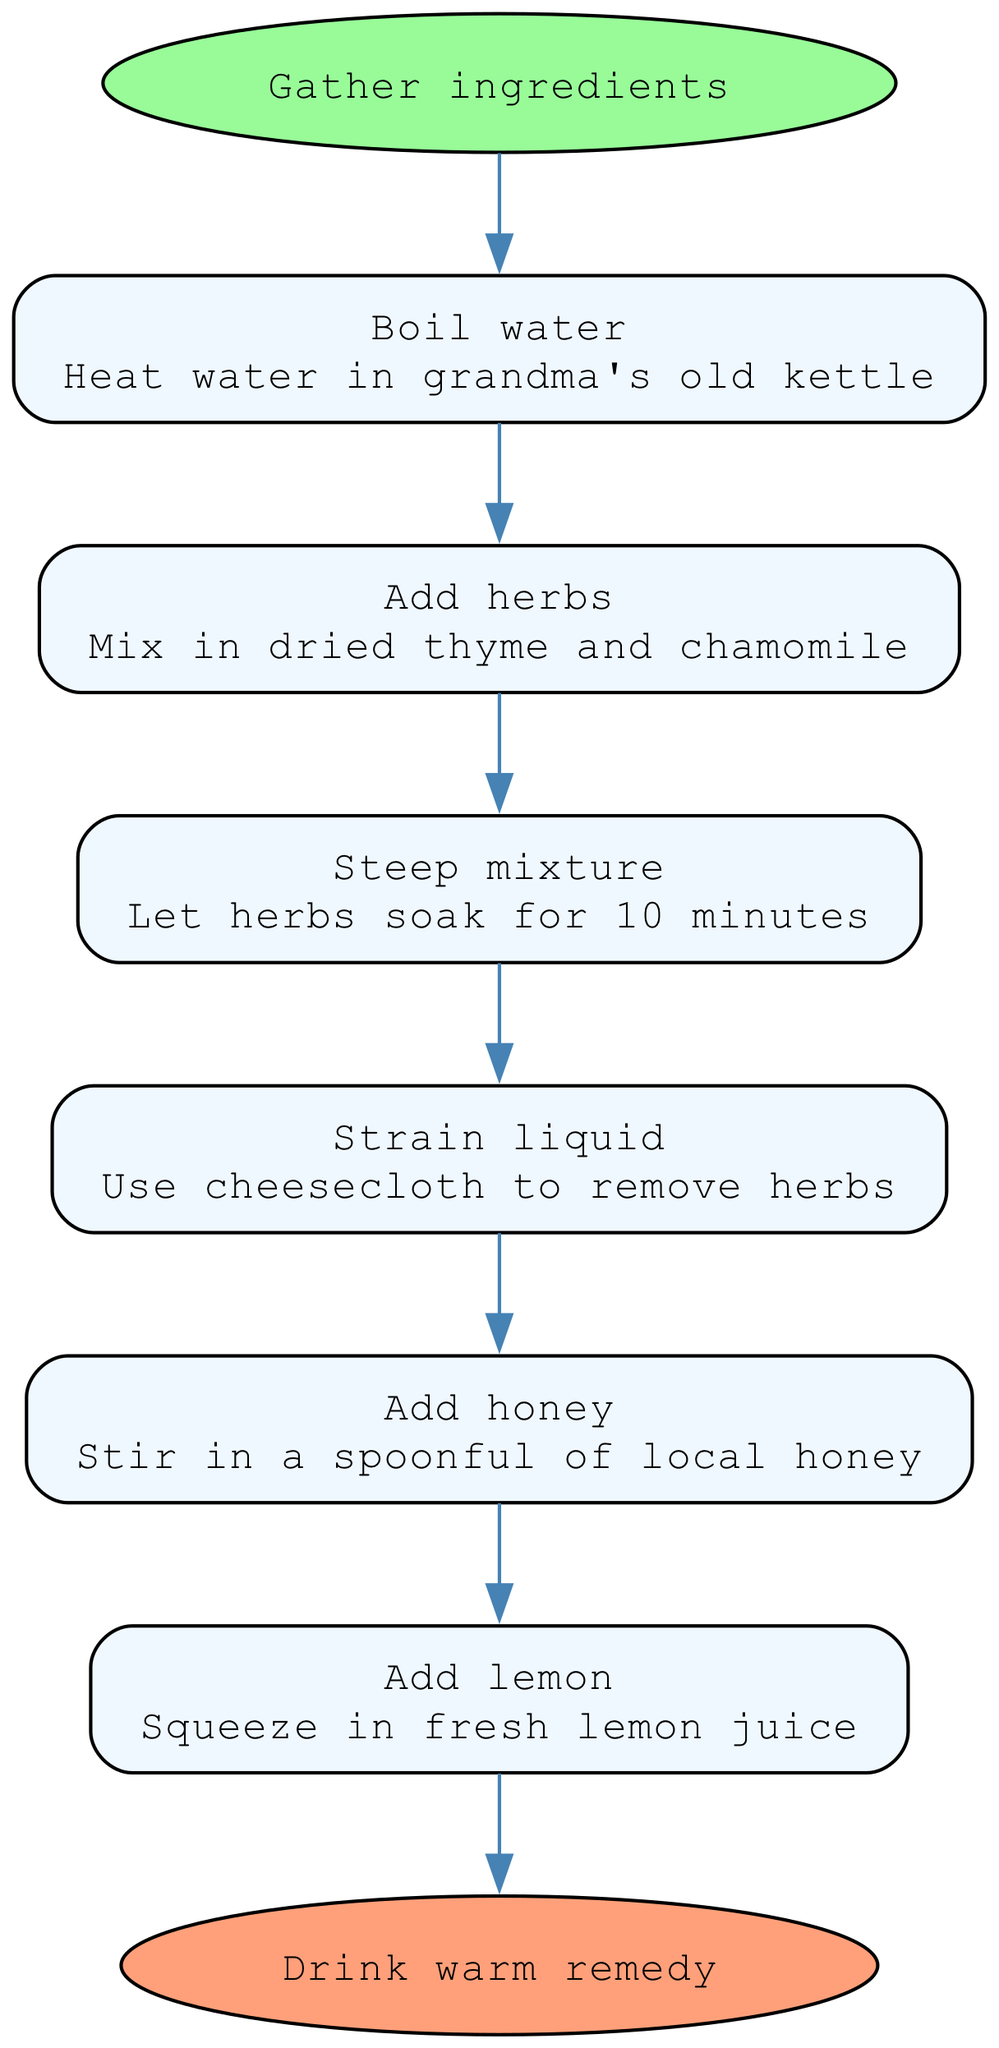What is the first step in the process? The first step is indicated by the start node, which points to the first action that needs to be taken. According to the diagram, the first step is "Boil water."
Answer: Boil water How many total steps are there? To find the total number of steps, we can count the number of intermediate nodes between the start and end nodes. There are six steps listed.
Answer: 6 What ingredient is added after boiling water? The sequence of steps indicates the order in which ingredients are added. After boiling water, the next action is to "Add herbs."
Answer: Add herbs What color is the end node? The end node is specified in the diagram with a particular fill color. According to the diagram, the end node is colored #FFA07A.
Answer: #FFA07A What herb is mentioned in the steps? By reviewing the descriptions of the steps, the specific herb that is included is highlighted in the step to "Add herbs." The herb mentioned is "thyme."
Answer: thyme Which step involves straining? By looking at the flow of the diagram, the step that involves straining happens after steeping the mixture. This action is detailed in the step "Strain liquid."
Answer: Strain liquid What do you add before drinking the remedy? The flow chart indicates that two ingredients are added just before the final step of drinking the remedy: honey and lemon juice. The specific step for that is "Add lemon."
Answer: Add lemon What is the last action to be taken? The last action in the sequence is clearly labeled in the end node of the diagram. The final action is to "Drink warm remedy."
Answer: Drink warm remedy What is the second step in this remedy-making process? By examining the order of the steps in the diagram, we can see that the second step follows right after the first step of boiling water. The second step is "Add herbs."
Answer: Add herbs 